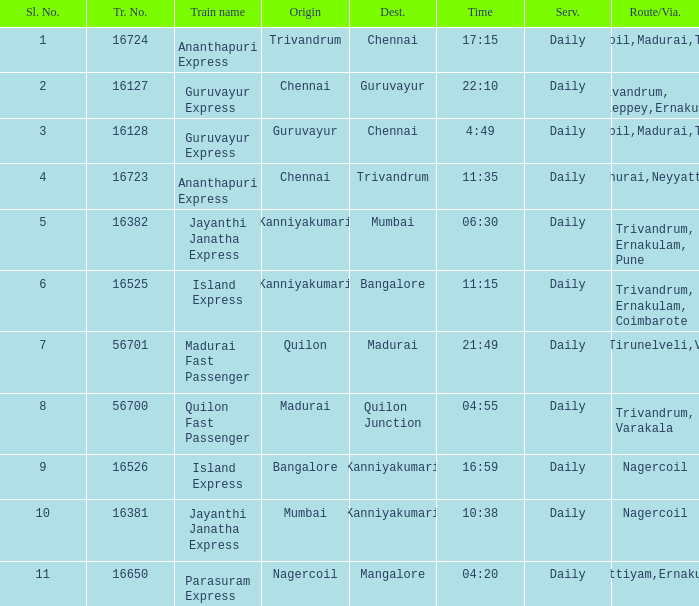What is the destination when the train number is 16526? Kanniyakumari. 